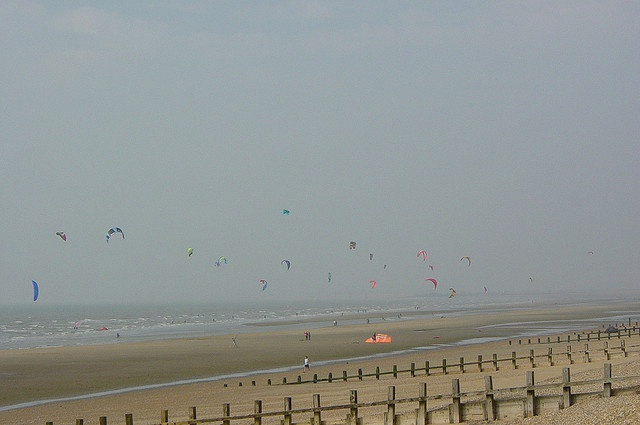Describe the objects in this image and their specific colors. I can see kite in darkgray, gray, and blue tones, kite in darkgray and gray tones, kite in darkgray and brown tones, people in darkgray, gray, and black tones, and kite in darkgray, teal, gray, and lightgreen tones in this image. 